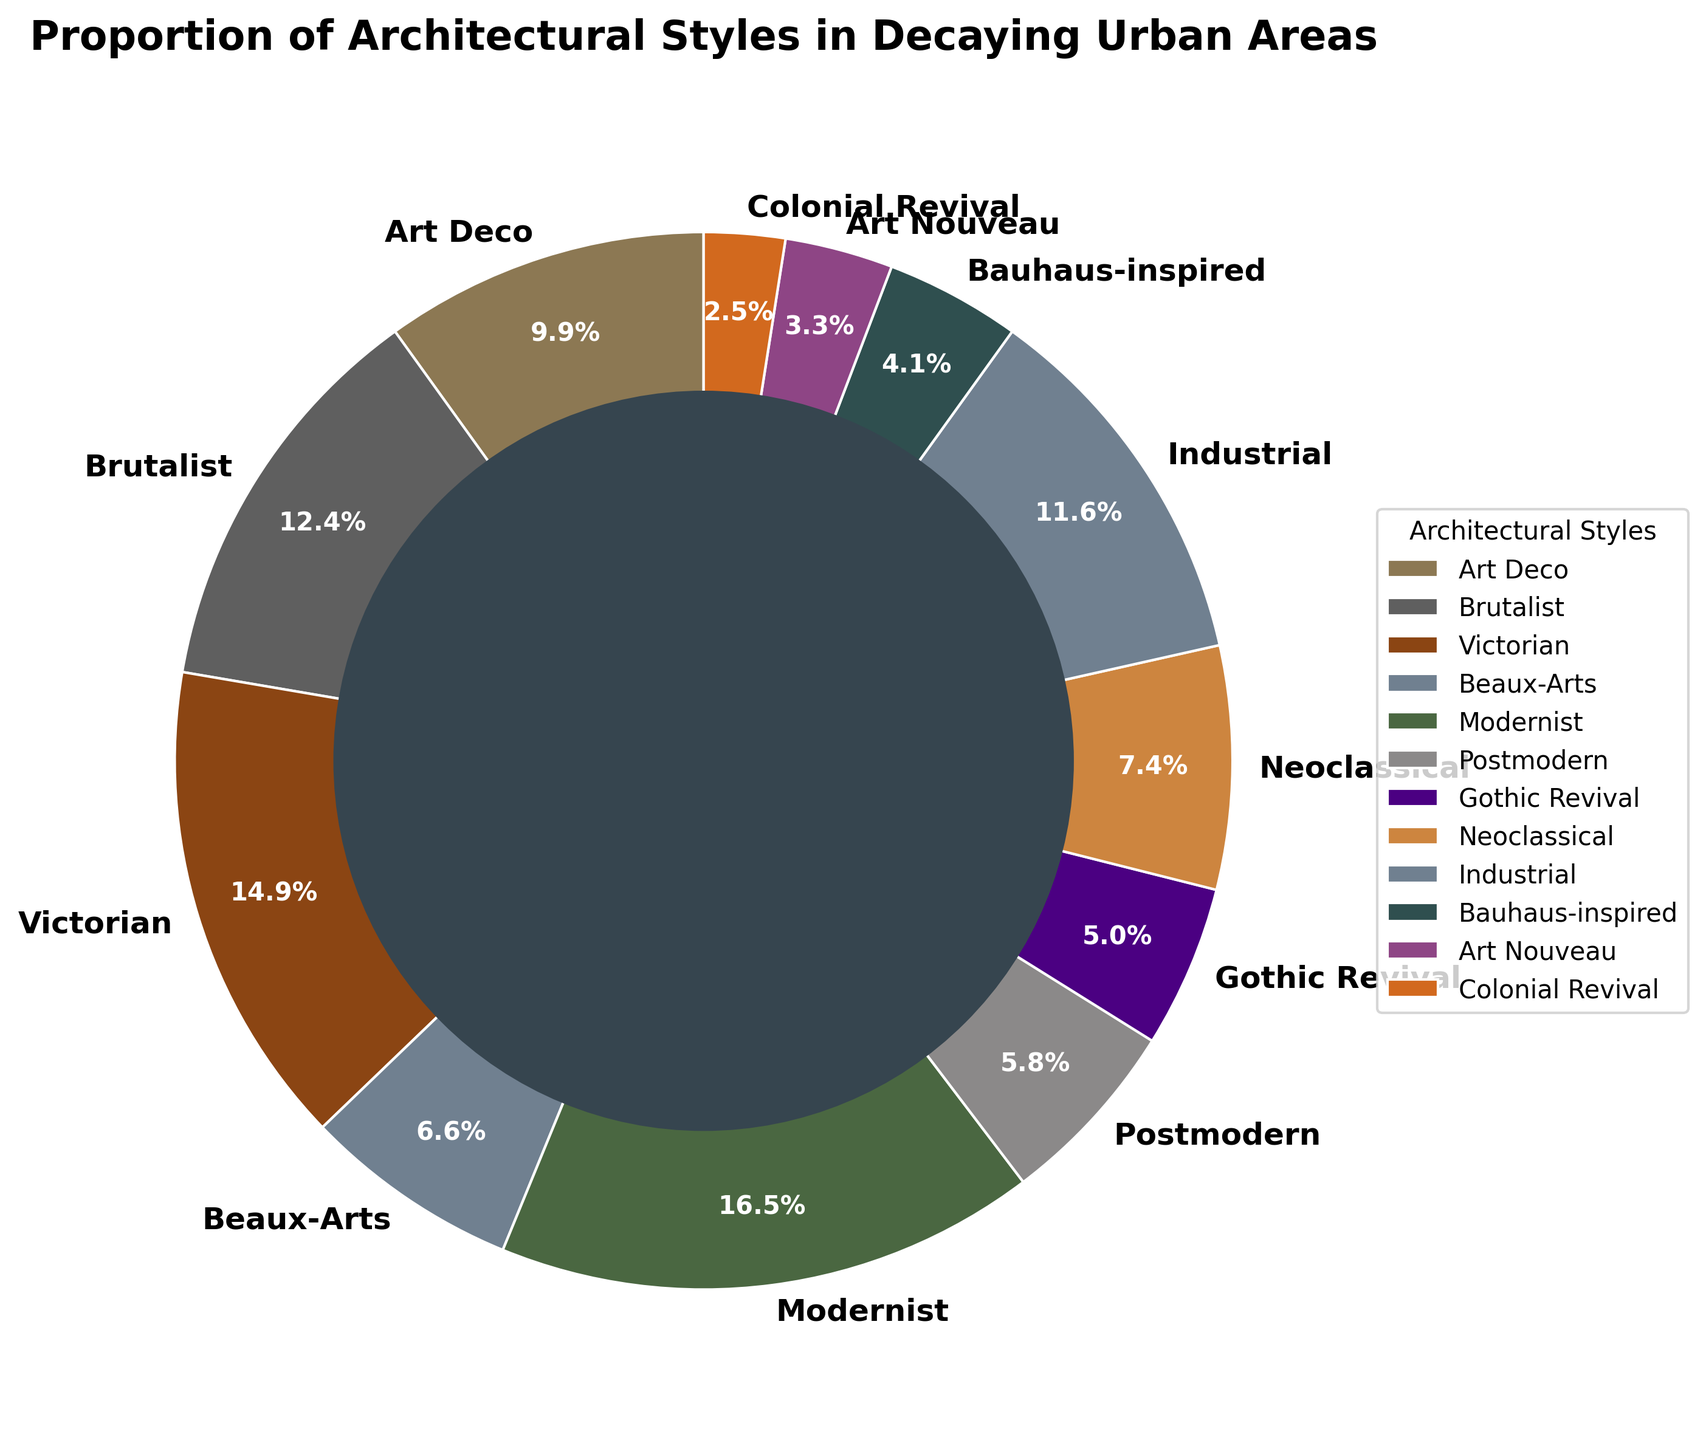What architectural style has the highest percentage? The pie chart indicates the percentage of each architectural style. By identifying the largest segment, we see that Modernist style has the highest percentage at 20%.
Answer: Modernist What is the combined percentage of Victorian and Art Deco styles? The pie chart shows Victorian at 18% and Art Deco at 12%. To find the combined percentage, add these two values: 18% + 12% = 30%.
Answer: 30% Which style has a smaller proportion: Colonial Revival or Art Nouveau? The pie chart indicates Colonial Revival at 3% and Art Nouveau at 4%. Comparatively, 3% is smaller than 4%, making Colonial Revival the smaller proportion.
Answer: Colonial Revival What is the percentage difference between Brutalist and Industrial styles? According to the pie chart, Brutalist is 15% and Industrial is 14%. The difference is calculated as 15% - 14% = 1%.
Answer: 1% Which styles have percentages less than 10%? The pie chart identifies Beaux-Arts (8%), Postmodern (7%), Gothic Revival (6%), Neoclassical (9%), Bauhaus-inspired (5%), Art Nouveau (4%), and Colonial Revival (3%) as the styles with percentages below 10%.
Answer: Beaux-Arts, Postmodern, Gothic Revival, Neoclassical, Bauhaus-inspired, Art Nouveau, Colonial Revival What is the average percentage of all architectural styles? Sum all percentages: 12+15+18+8+20+7+6+9+14+5+4+3 = 121%. There are 12 styles, so the average is 121% / 12 ≈ 10.08%.
Answer: 10.08% Which architectural style has a greenish color in the chart? The chart uses greenish shades for specific segments. By identifying the greenish segment visually, we see that Art Nouveau has the greenish color.
Answer: Art Nouveau Is the proportion of Postmodern greater than that of Gothic Revival and Bauhaus-inspired combined? From the chart, Postmodern is 7%, Gothic Revival is 6%, and Bauhaus-inspired is 5%. Combined, Gothic Revival and Bauhaus-inspired are 6% + 5% = 11%, which is greater than 7%.
Answer: No What is the total percentage of styles with more than 10%? The pie chart shows Modernist (20%), Victorian (18%), Brutalist (15%), Art Deco (12%), and Industrial (14%) all have more than 10%. Summing these gives 20% + 18% + 15% + 12% + 14% = 79%.
Answer: 79% Which architectural style is identified with an indigo color? By looking at the color segments, the indigo color represents Gothic Revival on the pie chart.
Answer: Gothic Revival 